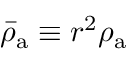Convert formula to latex. <formula><loc_0><loc_0><loc_500><loc_500>\bar { \rho } _ { a } \equiv r ^ { 2 } \rho _ { a }</formula> 